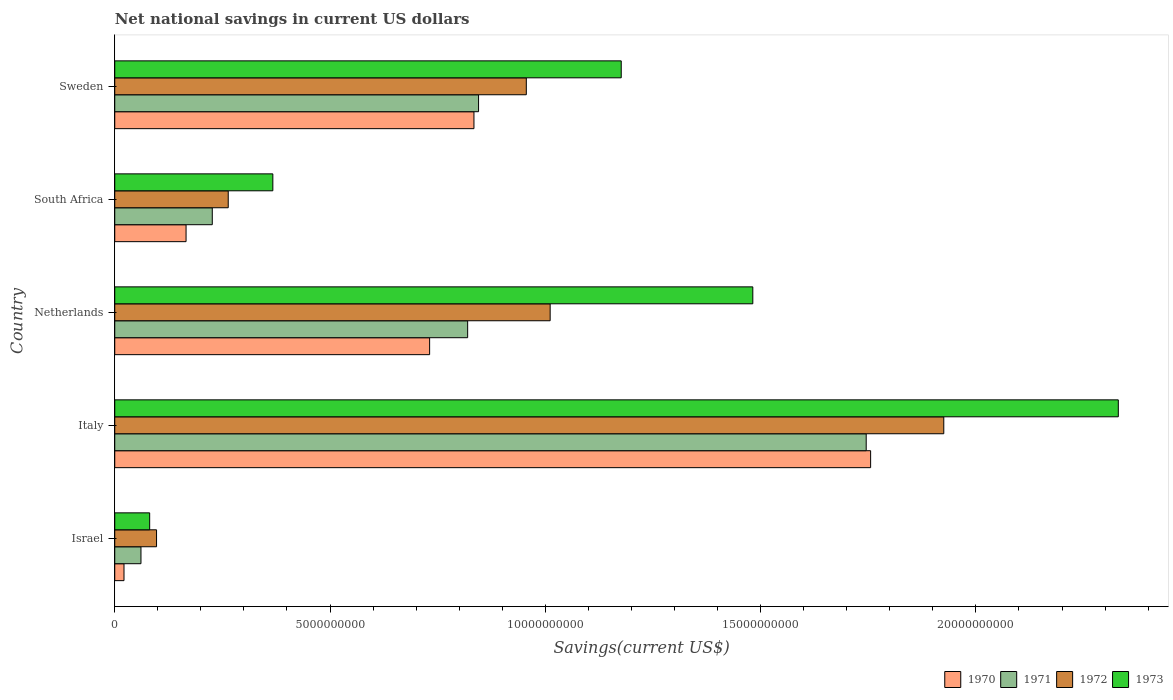How many groups of bars are there?
Your answer should be compact. 5. Are the number of bars per tick equal to the number of legend labels?
Your answer should be very brief. Yes. What is the label of the 4th group of bars from the top?
Ensure brevity in your answer.  Italy. In how many cases, is the number of bars for a given country not equal to the number of legend labels?
Keep it short and to the point. 0. What is the net national savings in 1970 in Israel?
Your answer should be very brief. 2.15e+08. Across all countries, what is the maximum net national savings in 1970?
Your answer should be very brief. 1.76e+1. Across all countries, what is the minimum net national savings in 1970?
Keep it short and to the point. 2.15e+08. In which country was the net national savings in 1973 minimum?
Provide a short and direct response. Israel. What is the total net national savings in 1973 in the graph?
Give a very brief answer. 5.44e+1. What is the difference between the net national savings in 1973 in Israel and that in Italy?
Ensure brevity in your answer.  -2.25e+1. What is the difference between the net national savings in 1971 in Sweden and the net national savings in 1972 in Israel?
Your answer should be compact. 7.48e+09. What is the average net national savings in 1972 per country?
Your response must be concise. 8.51e+09. What is the difference between the net national savings in 1971 and net national savings in 1973 in South Africa?
Your response must be concise. -1.41e+09. In how many countries, is the net national savings in 1972 greater than 6000000000 US$?
Your answer should be very brief. 3. What is the ratio of the net national savings in 1971 in Israel to that in Italy?
Ensure brevity in your answer.  0.03. Is the net national savings in 1971 in Israel less than that in Netherlands?
Keep it short and to the point. Yes. What is the difference between the highest and the second highest net national savings in 1972?
Provide a short and direct response. 9.14e+09. What is the difference between the highest and the lowest net national savings in 1973?
Keep it short and to the point. 2.25e+1. Is the sum of the net national savings in 1973 in Netherlands and South Africa greater than the maximum net national savings in 1972 across all countries?
Your response must be concise. No. Is it the case that in every country, the sum of the net national savings in 1972 and net national savings in 1973 is greater than the sum of net national savings in 1970 and net national savings in 1971?
Make the answer very short. No. What does the 4th bar from the top in Israel represents?
Ensure brevity in your answer.  1970. What does the 3rd bar from the bottom in South Africa represents?
Your response must be concise. 1972. Is it the case that in every country, the sum of the net national savings in 1972 and net national savings in 1970 is greater than the net national savings in 1971?
Your response must be concise. Yes. How many bars are there?
Make the answer very short. 20. Are all the bars in the graph horizontal?
Provide a short and direct response. Yes. Are the values on the major ticks of X-axis written in scientific E-notation?
Keep it short and to the point. No. Does the graph contain any zero values?
Keep it short and to the point. No. How many legend labels are there?
Your answer should be very brief. 4. What is the title of the graph?
Make the answer very short. Net national savings in current US dollars. What is the label or title of the X-axis?
Offer a very short reply. Savings(current US$). What is the label or title of the Y-axis?
Ensure brevity in your answer.  Country. What is the Savings(current US$) in 1970 in Israel?
Ensure brevity in your answer.  2.15e+08. What is the Savings(current US$) in 1971 in Israel?
Your answer should be compact. 6.09e+08. What is the Savings(current US$) of 1972 in Israel?
Offer a very short reply. 9.71e+08. What is the Savings(current US$) in 1973 in Israel?
Offer a very short reply. 8.11e+08. What is the Savings(current US$) in 1970 in Italy?
Provide a short and direct response. 1.76e+1. What is the Savings(current US$) in 1971 in Italy?
Your response must be concise. 1.75e+1. What is the Savings(current US$) in 1972 in Italy?
Your response must be concise. 1.93e+1. What is the Savings(current US$) of 1973 in Italy?
Provide a short and direct response. 2.33e+1. What is the Savings(current US$) in 1970 in Netherlands?
Ensure brevity in your answer.  7.31e+09. What is the Savings(current US$) in 1971 in Netherlands?
Provide a succinct answer. 8.20e+09. What is the Savings(current US$) of 1972 in Netherlands?
Offer a very short reply. 1.01e+1. What is the Savings(current US$) in 1973 in Netherlands?
Your answer should be very brief. 1.48e+1. What is the Savings(current US$) of 1970 in South Africa?
Offer a terse response. 1.66e+09. What is the Savings(current US$) of 1971 in South Africa?
Give a very brief answer. 2.27e+09. What is the Savings(current US$) of 1972 in South Africa?
Keep it short and to the point. 2.64e+09. What is the Savings(current US$) of 1973 in South Africa?
Your answer should be compact. 3.67e+09. What is the Savings(current US$) in 1970 in Sweden?
Keep it short and to the point. 8.34e+09. What is the Savings(current US$) of 1971 in Sweden?
Offer a very short reply. 8.45e+09. What is the Savings(current US$) of 1972 in Sweden?
Your answer should be very brief. 9.56e+09. What is the Savings(current US$) in 1973 in Sweden?
Your response must be concise. 1.18e+1. Across all countries, what is the maximum Savings(current US$) in 1970?
Your answer should be very brief. 1.76e+1. Across all countries, what is the maximum Savings(current US$) of 1971?
Provide a short and direct response. 1.75e+1. Across all countries, what is the maximum Savings(current US$) in 1972?
Your response must be concise. 1.93e+1. Across all countries, what is the maximum Savings(current US$) of 1973?
Ensure brevity in your answer.  2.33e+1. Across all countries, what is the minimum Savings(current US$) of 1970?
Offer a terse response. 2.15e+08. Across all countries, what is the minimum Savings(current US$) of 1971?
Offer a very short reply. 6.09e+08. Across all countries, what is the minimum Savings(current US$) of 1972?
Provide a short and direct response. 9.71e+08. Across all countries, what is the minimum Savings(current US$) of 1973?
Make the answer very short. 8.11e+08. What is the total Savings(current US$) in 1970 in the graph?
Offer a very short reply. 3.51e+1. What is the total Savings(current US$) of 1971 in the graph?
Provide a short and direct response. 3.70e+1. What is the total Savings(current US$) of 1972 in the graph?
Offer a terse response. 4.25e+1. What is the total Savings(current US$) in 1973 in the graph?
Your answer should be compact. 5.44e+1. What is the difference between the Savings(current US$) in 1970 in Israel and that in Italy?
Your answer should be very brief. -1.73e+1. What is the difference between the Savings(current US$) in 1971 in Israel and that in Italy?
Make the answer very short. -1.68e+1. What is the difference between the Savings(current US$) of 1972 in Israel and that in Italy?
Give a very brief answer. -1.83e+1. What is the difference between the Savings(current US$) in 1973 in Israel and that in Italy?
Your answer should be compact. -2.25e+1. What is the difference between the Savings(current US$) of 1970 in Israel and that in Netherlands?
Keep it short and to the point. -7.10e+09. What is the difference between the Savings(current US$) in 1971 in Israel and that in Netherlands?
Provide a succinct answer. -7.59e+09. What is the difference between the Savings(current US$) of 1972 in Israel and that in Netherlands?
Ensure brevity in your answer.  -9.14e+09. What is the difference between the Savings(current US$) in 1973 in Israel and that in Netherlands?
Your answer should be very brief. -1.40e+1. What is the difference between the Savings(current US$) of 1970 in Israel and that in South Africa?
Your answer should be compact. -1.44e+09. What is the difference between the Savings(current US$) of 1971 in Israel and that in South Africa?
Give a very brief answer. -1.66e+09. What is the difference between the Savings(current US$) of 1972 in Israel and that in South Africa?
Ensure brevity in your answer.  -1.66e+09. What is the difference between the Savings(current US$) in 1973 in Israel and that in South Africa?
Ensure brevity in your answer.  -2.86e+09. What is the difference between the Savings(current US$) in 1970 in Israel and that in Sweden?
Give a very brief answer. -8.13e+09. What is the difference between the Savings(current US$) of 1971 in Israel and that in Sweden?
Your answer should be compact. -7.84e+09. What is the difference between the Savings(current US$) in 1972 in Israel and that in Sweden?
Give a very brief answer. -8.59e+09. What is the difference between the Savings(current US$) in 1973 in Israel and that in Sweden?
Give a very brief answer. -1.10e+1. What is the difference between the Savings(current US$) in 1970 in Italy and that in Netherlands?
Make the answer very short. 1.02e+1. What is the difference between the Savings(current US$) of 1971 in Italy and that in Netherlands?
Give a very brief answer. 9.26e+09. What is the difference between the Savings(current US$) of 1972 in Italy and that in Netherlands?
Your answer should be very brief. 9.14e+09. What is the difference between the Savings(current US$) of 1973 in Italy and that in Netherlands?
Offer a very short reply. 8.49e+09. What is the difference between the Savings(current US$) of 1970 in Italy and that in South Africa?
Your response must be concise. 1.59e+1. What is the difference between the Savings(current US$) of 1971 in Italy and that in South Africa?
Provide a succinct answer. 1.52e+1. What is the difference between the Savings(current US$) of 1972 in Italy and that in South Africa?
Make the answer very short. 1.66e+1. What is the difference between the Savings(current US$) of 1973 in Italy and that in South Africa?
Your answer should be compact. 1.96e+1. What is the difference between the Savings(current US$) of 1970 in Italy and that in Sweden?
Offer a terse response. 9.21e+09. What is the difference between the Savings(current US$) in 1971 in Italy and that in Sweden?
Offer a terse response. 9.00e+09. What is the difference between the Savings(current US$) in 1972 in Italy and that in Sweden?
Offer a terse response. 9.70e+09. What is the difference between the Savings(current US$) of 1973 in Italy and that in Sweden?
Provide a short and direct response. 1.15e+1. What is the difference between the Savings(current US$) in 1970 in Netherlands and that in South Africa?
Provide a short and direct response. 5.66e+09. What is the difference between the Savings(current US$) in 1971 in Netherlands and that in South Africa?
Offer a terse response. 5.93e+09. What is the difference between the Savings(current US$) in 1972 in Netherlands and that in South Africa?
Offer a terse response. 7.48e+09. What is the difference between the Savings(current US$) in 1973 in Netherlands and that in South Africa?
Give a very brief answer. 1.11e+1. What is the difference between the Savings(current US$) of 1970 in Netherlands and that in Sweden?
Your response must be concise. -1.03e+09. What is the difference between the Savings(current US$) of 1971 in Netherlands and that in Sweden?
Your answer should be very brief. -2.53e+08. What is the difference between the Savings(current US$) of 1972 in Netherlands and that in Sweden?
Make the answer very short. 5.54e+08. What is the difference between the Savings(current US$) of 1973 in Netherlands and that in Sweden?
Offer a very short reply. 3.06e+09. What is the difference between the Savings(current US$) in 1970 in South Africa and that in Sweden?
Keep it short and to the point. -6.69e+09. What is the difference between the Savings(current US$) of 1971 in South Africa and that in Sweden?
Give a very brief answer. -6.18e+09. What is the difference between the Savings(current US$) in 1972 in South Africa and that in Sweden?
Ensure brevity in your answer.  -6.92e+09. What is the difference between the Savings(current US$) of 1973 in South Africa and that in Sweden?
Make the answer very short. -8.09e+09. What is the difference between the Savings(current US$) in 1970 in Israel and the Savings(current US$) in 1971 in Italy?
Provide a short and direct response. -1.72e+1. What is the difference between the Savings(current US$) in 1970 in Israel and the Savings(current US$) in 1972 in Italy?
Keep it short and to the point. -1.90e+1. What is the difference between the Savings(current US$) in 1970 in Israel and the Savings(current US$) in 1973 in Italy?
Your response must be concise. -2.31e+1. What is the difference between the Savings(current US$) in 1971 in Israel and the Savings(current US$) in 1972 in Italy?
Your response must be concise. -1.86e+1. What is the difference between the Savings(current US$) of 1971 in Israel and the Savings(current US$) of 1973 in Italy?
Offer a very short reply. -2.27e+1. What is the difference between the Savings(current US$) of 1972 in Israel and the Savings(current US$) of 1973 in Italy?
Keep it short and to the point. -2.23e+1. What is the difference between the Savings(current US$) in 1970 in Israel and the Savings(current US$) in 1971 in Netherlands?
Ensure brevity in your answer.  -7.98e+09. What is the difference between the Savings(current US$) in 1970 in Israel and the Savings(current US$) in 1972 in Netherlands?
Your answer should be compact. -9.90e+09. What is the difference between the Savings(current US$) in 1970 in Israel and the Savings(current US$) in 1973 in Netherlands?
Your answer should be very brief. -1.46e+1. What is the difference between the Savings(current US$) of 1971 in Israel and the Savings(current US$) of 1972 in Netherlands?
Your answer should be very brief. -9.50e+09. What is the difference between the Savings(current US$) in 1971 in Israel and the Savings(current US$) in 1973 in Netherlands?
Give a very brief answer. -1.42e+1. What is the difference between the Savings(current US$) of 1972 in Israel and the Savings(current US$) of 1973 in Netherlands?
Give a very brief answer. -1.38e+1. What is the difference between the Savings(current US$) in 1970 in Israel and the Savings(current US$) in 1971 in South Africa?
Ensure brevity in your answer.  -2.05e+09. What is the difference between the Savings(current US$) of 1970 in Israel and the Savings(current US$) of 1972 in South Africa?
Keep it short and to the point. -2.42e+09. What is the difference between the Savings(current US$) in 1970 in Israel and the Savings(current US$) in 1973 in South Africa?
Ensure brevity in your answer.  -3.46e+09. What is the difference between the Savings(current US$) of 1971 in Israel and the Savings(current US$) of 1972 in South Africa?
Offer a very short reply. -2.03e+09. What is the difference between the Savings(current US$) in 1971 in Israel and the Savings(current US$) in 1973 in South Africa?
Keep it short and to the point. -3.06e+09. What is the difference between the Savings(current US$) of 1972 in Israel and the Savings(current US$) of 1973 in South Africa?
Your answer should be very brief. -2.70e+09. What is the difference between the Savings(current US$) in 1970 in Israel and the Savings(current US$) in 1971 in Sweden?
Your answer should be compact. -8.23e+09. What is the difference between the Savings(current US$) of 1970 in Israel and the Savings(current US$) of 1972 in Sweden?
Your response must be concise. -9.34e+09. What is the difference between the Savings(current US$) of 1970 in Israel and the Savings(current US$) of 1973 in Sweden?
Your answer should be compact. -1.15e+1. What is the difference between the Savings(current US$) of 1971 in Israel and the Savings(current US$) of 1972 in Sweden?
Make the answer very short. -8.95e+09. What is the difference between the Savings(current US$) in 1971 in Israel and the Savings(current US$) in 1973 in Sweden?
Ensure brevity in your answer.  -1.12e+1. What is the difference between the Savings(current US$) of 1972 in Israel and the Savings(current US$) of 1973 in Sweden?
Make the answer very short. -1.08e+1. What is the difference between the Savings(current US$) in 1970 in Italy and the Savings(current US$) in 1971 in Netherlands?
Your answer should be compact. 9.36e+09. What is the difference between the Savings(current US$) in 1970 in Italy and the Savings(current US$) in 1972 in Netherlands?
Keep it short and to the point. 7.44e+09. What is the difference between the Savings(current US$) in 1970 in Italy and the Savings(current US$) in 1973 in Netherlands?
Provide a succinct answer. 2.74e+09. What is the difference between the Savings(current US$) in 1971 in Italy and the Savings(current US$) in 1972 in Netherlands?
Your response must be concise. 7.34e+09. What is the difference between the Savings(current US$) of 1971 in Italy and the Savings(current US$) of 1973 in Netherlands?
Your answer should be very brief. 2.63e+09. What is the difference between the Savings(current US$) of 1972 in Italy and the Savings(current US$) of 1973 in Netherlands?
Provide a succinct answer. 4.44e+09. What is the difference between the Savings(current US$) in 1970 in Italy and the Savings(current US$) in 1971 in South Africa?
Give a very brief answer. 1.53e+1. What is the difference between the Savings(current US$) in 1970 in Italy and the Savings(current US$) in 1972 in South Africa?
Ensure brevity in your answer.  1.49e+1. What is the difference between the Savings(current US$) of 1970 in Italy and the Savings(current US$) of 1973 in South Africa?
Your response must be concise. 1.39e+1. What is the difference between the Savings(current US$) of 1971 in Italy and the Savings(current US$) of 1972 in South Africa?
Make the answer very short. 1.48e+1. What is the difference between the Savings(current US$) in 1971 in Italy and the Savings(current US$) in 1973 in South Africa?
Ensure brevity in your answer.  1.38e+1. What is the difference between the Savings(current US$) of 1972 in Italy and the Savings(current US$) of 1973 in South Africa?
Provide a short and direct response. 1.56e+1. What is the difference between the Savings(current US$) in 1970 in Italy and the Savings(current US$) in 1971 in Sweden?
Make the answer very short. 9.11e+09. What is the difference between the Savings(current US$) in 1970 in Italy and the Savings(current US$) in 1972 in Sweden?
Offer a terse response. 8.00e+09. What is the difference between the Savings(current US$) in 1970 in Italy and the Savings(current US$) in 1973 in Sweden?
Your response must be concise. 5.79e+09. What is the difference between the Savings(current US$) of 1971 in Italy and the Savings(current US$) of 1972 in Sweden?
Your answer should be compact. 7.89e+09. What is the difference between the Savings(current US$) in 1971 in Italy and the Savings(current US$) in 1973 in Sweden?
Make the answer very short. 5.69e+09. What is the difference between the Savings(current US$) in 1972 in Italy and the Savings(current US$) in 1973 in Sweden?
Provide a succinct answer. 7.49e+09. What is the difference between the Savings(current US$) in 1970 in Netherlands and the Savings(current US$) in 1971 in South Africa?
Your answer should be very brief. 5.05e+09. What is the difference between the Savings(current US$) in 1970 in Netherlands and the Savings(current US$) in 1972 in South Africa?
Provide a succinct answer. 4.68e+09. What is the difference between the Savings(current US$) of 1970 in Netherlands and the Savings(current US$) of 1973 in South Africa?
Ensure brevity in your answer.  3.64e+09. What is the difference between the Savings(current US$) of 1971 in Netherlands and the Savings(current US$) of 1972 in South Africa?
Make the answer very short. 5.56e+09. What is the difference between the Savings(current US$) of 1971 in Netherlands and the Savings(current US$) of 1973 in South Africa?
Your answer should be compact. 4.52e+09. What is the difference between the Savings(current US$) in 1972 in Netherlands and the Savings(current US$) in 1973 in South Africa?
Give a very brief answer. 6.44e+09. What is the difference between the Savings(current US$) of 1970 in Netherlands and the Savings(current US$) of 1971 in Sweden?
Your response must be concise. -1.14e+09. What is the difference between the Savings(current US$) of 1970 in Netherlands and the Savings(current US$) of 1972 in Sweden?
Your answer should be compact. -2.25e+09. What is the difference between the Savings(current US$) in 1970 in Netherlands and the Savings(current US$) in 1973 in Sweden?
Provide a short and direct response. -4.45e+09. What is the difference between the Savings(current US$) in 1971 in Netherlands and the Savings(current US$) in 1972 in Sweden?
Your response must be concise. -1.36e+09. What is the difference between the Savings(current US$) in 1971 in Netherlands and the Savings(current US$) in 1973 in Sweden?
Your answer should be very brief. -3.57e+09. What is the difference between the Savings(current US$) of 1972 in Netherlands and the Savings(current US$) of 1973 in Sweden?
Ensure brevity in your answer.  -1.65e+09. What is the difference between the Savings(current US$) of 1970 in South Africa and the Savings(current US$) of 1971 in Sweden?
Provide a short and direct response. -6.79e+09. What is the difference between the Savings(current US$) in 1970 in South Africa and the Savings(current US$) in 1972 in Sweden?
Your answer should be very brief. -7.90e+09. What is the difference between the Savings(current US$) in 1970 in South Africa and the Savings(current US$) in 1973 in Sweden?
Provide a short and direct response. -1.01e+1. What is the difference between the Savings(current US$) in 1971 in South Africa and the Savings(current US$) in 1972 in Sweden?
Give a very brief answer. -7.29e+09. What is the difference between the Savings(current US$) in 1971 in South Africa and the Savings(current US$) in 1973 in Sweden?
Ensure brevity in your answer.  -9.50e+09. What is the difference between the Savings(current US$) of 1972 in South Africa and the Savings(current US$) of 1973 in Sweden?
Provide a short and direct response. -9.13e+09. What is the average Savings(current US$) in 1970 per country?
Offer a terse response. 7.02e+09. What is the average Savings(current US$) in 1971 per country?
Your response must be concise. 7.39e+09. What is the average Savings(current US$) in 1972 per country?
Keep it short and to the point. 8.51e+09. What is the average Savings(current US$) of 1973 per country?
Ensure brevity in your answer.  1.09e+1. What is the difference between the Savings(current US$) in 1970 and Savings(current US$) in 1971 in Israel?
Keep it short and to the point. -3.94e+08. What is the difference between the Savings(current US$) of 1970 and Savings(current US$) of 1972 in Israel?
Give a very brief answer. -7.56e+08. What is the difference between the Savings(current US$) in 1970 and Savings(current US$) in 1973 in Israel?
Offer a terse response. -5.96e+08. What is the difference between the Savings(current US$) in 1971 and Savings(current US$) in 1972 in Israel?
Your response must be concise. -3.62e+08. What is the difference between the Savings(current US$) of 1971 and Savings(current US$) of 1973 in Israel?
Offer a terse response. -2.02e+08. What is the difference between the Savings(current US$) in 1972 and Savings(current US$) in 1973 in Israel?
Provide a short and direct response. 1.60e+08. What is the difference between the Savings(current US$) of 1970 and Savings(current US$) of 1971 in Italy?
Ensure brevity in your answer.  1.03e+08. What is the difference between the Savings(current US$) of 1970 and Savings(current US$) of 1972 in Italy?
Ensure brevity in your answer.  -1.70e+09. What is the difference between the Savings(current US$) of 1970 and Savings(current US$) of 1973 in Italy?
Keep it short and to the point. -5.75e+09. What is the difference between the Savings(current US$) in 1971 and Savings(current US$) in 1972 in Italy?
Keep it short and to the point. -1.80e+09. What is the difference between the Savings(current US$) of 1971 and Savings(current US$) of 1973 in Italy?
Your answer should be very brief. -5.86e+09. What is the difference between the Savings(current US$) in 1972 and Savings(current US$) in 1973 in Italy?
Make the answer very short. -4.05e+09. What is the difference between the Savings(current US$) in 1970 and Savings(current US$) in 1971 in Netherlands?
Your answer should be very brief. -8.83e+08. What is the difference between the Savings(current US$) in 1970 and Savings(current US$) in 1972 in Netherlands?
Your answer should be very brief. -2.80e+09. What is the difference between the Savings(current US$) in 1970 and Savings(current US$) in 1973 in Netherlands?
Offer a terse response. -7.51e+09. What is the difference between the Savings(current US$) in 1971 and Savings(current US$) in 1972 in Netherlands?
Ensure brevity in your answer.  -1.92e+09. What is the difference between the Savings(current US$) of 1971 and Savings(current US$) of 1973 in Netherlands?
Give a very brief answer. -6.62e+09. What is the difference between the Savings(current US$) in 1972 and Savings(current US$) in 1973 in Netherlands?
Provide a succinct answer. -4.71e+09. What is the difference between the Savings(current US$) in 1970 and Savings(current US$) in 1971 in South Africa?
Your answer should be very brief. -6.09e+08. What is the difference between the Savings(current US$) of 1970 and Savings(current US$) of 1972 in South Africa?
Provide a short and direct response. -9.79e+08. What is the difference between the Savings(current US$) in 1970 and Savings(current US$) in 1973 in South Africa?
Give a very brief answer. -2.02e+09. What is the difference between the Savings(current US$) of 1971 and Savings(current US$) of 1972 in South Africa?
Your answer should be very brief. -3.70e+08. What is the difference between the Savings(current US$) in 1971 and Savings(current US$) in 1973 in South Africa?
Your answer should be compact. -1.41e+09. What is the difference between the Savings(current US$) of 1972 and Savings(current US$) of 1973 in South Africa?
Give a very brief answer. -1.04e+09. What is the difference between the Savings(current US$) in 1970 and Savings(current US$) in 1971 in Sweden?
Offer a very short reply. -1.07e+08. What is the difference between the Savings(current US$) of 1970 and Savings(current US$) of 1972 in Sweden?
Offer a terse response. -1.22e+09. What is the difference between the Savings(current US$) of 1970 and Savings(current US$) of 1973 in Sweden?
Provide a short and direct response. -3.42e+09. What is the difference between the Savings(current US$) in 1971 and Savings(current US$) in 1972 in Sweden?
Your answer should be very brief. -1.11e+09. What is the difference between the Savings(current US$) in 1971 and Savings(current US$) in 1973 in Sweden?
Make the answer very short. -3.31e+09. What is the difference between the Savings(current US$) in 1972 and Savings(current US$) in 1973 in Sweden?
Your answer should be very brief. -2.20e+09. What is the ratio of the Savings(current US$) of 1970 in Israel to that in Italy?
Keep it short and to the point. 0.01. What is the ratio of the Savings(current US$) of 1971 in Israel to that in Italy?
Your response must be concise. 0.03. What is the ratio of the Savings(current US$) of 1972 in Israel to that in Italy?
Give a very brief answer. 0.05. What is the ratio of the Savings(current US$) of 1973 in Israel to that in Italy?
Give a very brief answer. 0.03. What is the ratio of the Savings(current US$) in 1970 in Israel to that in Netherlands?
Provide a short and direct response. 0.03. What is the ratio of the Savings(current US$) in 1971 in Israel to that in Netherlands?
Keep it short and to the point. 0.07. What is the ratio of the Savings(current US$) of 1972 in Israel to that in Netherlands?
Provide a succinct answer. 0.1. What is the ratio of the Savings(current US$) of 1973 in Israel to that in Netherlands?
Provide a short and direct response. 0.05. What is the ratio of the Savings(current US$) of 1970 in Israel to that in South Africa?
Your answer should be very brief. 0.13. What is the ratio of the Savings(current US$) of 1971 in Israel to that in South Africa?
Provide a short and direct response. 0.27. What is the ratio of the Savings(current US$) of 1972 in Israel to that in South Africa?
Provide a succinct answer. 0.37. What is the ratio of the Savings(current US$) in 1973 in Israel to that in South Africa?
Offer a terse response. 0.22. What is the ratio of the Savings(current US$) in 1970 in Israel to that in Sweden?
Your response must be concise. 0.03. What is the ratio of the Savings(current US$) of 1971 in Israel to that in Sweden?
Your answer should be very brief. 0.07. What is the ratio of the Savings(current US$) of 1972 in Israel to that in Sweden?
Offer a terse response. 0.1. What is the ratio of the Savings(current US$) of 1973 in Israel to that in Sweden?
Provide a short and direct response. 0.07. What is the ratio of the Savings(current US$) in 1970 in Italy to that in Netherlands?
Give a very brief answer. 2.4. What is the ratio of the Savings(current US$) in 1971 in Italy to that in Netherlands?
Your answer should be compact. 2.13. What is the ratio of the Savings(current US$) in 1972 in Italy to that in Netherlands?
Your response must be concise. 1.9. What is the ratio of the Savings(current US$) of 1973 in Italy to that in Netherlands?
Your answer should be very brief. 1.57. What is the ratio of the Savings(current US$) in 1970 in Italy to that in South Africa?
Provide a short and direct response. 10.6. What is the ratio of the Savings(current US$) in 1971 in Italy to that in South Africa?
Give a very brief answer. 7.7. What is the ratio of the Savings(current US$) in 1972 in Italy to that in South Africa?
Make the answer very short. 7.31. What is the ratio of the Savings(current US$) of 1973 in Italy to that in South Africa?
Offer a terse response. 6.35. What is the ratio of the Savings(current US$) in 1970 in Italy to that in Sweden?
Your answer should be compact. 2.1. What is the ratio of the Savings(current US$) of 1971 in Italy to that in Sweden?
Offer a terse response. 2.07. What is the ratio of the Savings(current US$) of 1972 in Italy to that in Sweden?
Make the answer very short. 2.01. What is the ratio of the Savings(current US$) in 1973 in Italy to that in Sweden?
Give a very brief answer. 1.98. What is the ratio of the Savings(current US$) in 1970 in Netherlands to that in South Africa?
Give a very brief answer. 4.42. What is the ratio of the Savings(current US$) in 1971 in Netherlands to that in South Africa?
Your response must be concise. 3.62. What is the ratio of the Savings(current US$) in 1972 in Netherlands to that in South Africa?
Keep it short and to the point. 3.84. What is the ratio of the Savings(current US$) in 1973 in Netherlands to that in South Africa?
Keep it short and to the point. 4.04. What is the ratio of the Savings(current US$) of 1970 in Netherlands to that in Sweden?
Offer a very short reply. 0.88. What is the ratio of the Savings(current US$) of 1971 in Netherlands to that in Sweden?
Give a very brief answer. 0.97. What is the ratio of the Savings(current US$) in 1972 in Netherlands to that in Sweden?
Make the answer very short. 1.06. What is the ratio of the Savings(current US$) of 1973 in Netherlands to that in Sweden?
Your answer should be compact. 1.26. What is the ratio of the Savings(current US$) in 1970 in South Africa to that in Sweden?
Offer a terse response. 0.2. What is the ratio of the Savings(current US$) of 1971 in South Africa to that in Sweden?
Ensure brevity in your answer.  0.27. What is the ratio of the Savings(current US$) of 1972 in South Africa to that in Sweden?
Your answer should be very brief. 0.28. What is the ratio of the Savings(current US$) of 1973 in South Africa to that in Sweden?
Ensure brevity in your answer.  0.31. What is the difference between the highest and the second highest Savings(current US$) of 1970?
Your answer should be very brief. 9.21e+09. What is the difference between the highest and the second highest Savings(current US$) in 1971?
Your answer should be very brief. 9.00e+09. What is the difference between the highest and the second highest Savings(current US$) in 1972?
Your answer should be very brief. 9.14e+09. What is the difference between the highest and the second highest Savings(current US$) of 1973?
Ensure brevity in your answer.  8.49e+09. What is the difference between the highest and the lowest Savings(current US$) in 1970?
Make the answer very short. 1.73e+1. What is the difference between the highest and the lowest Savings(current US$) of 1971?
Give a very brief answer. 1.68e+1. What is the difference between the highest and the lowest Savings(current US$) of 1972?
Give a very brief answer. 1.83e+1. What is the difference between the highest and the lowest Savings(current US$) in 1973?
Provide a short and direct response. 2.25e+1. 